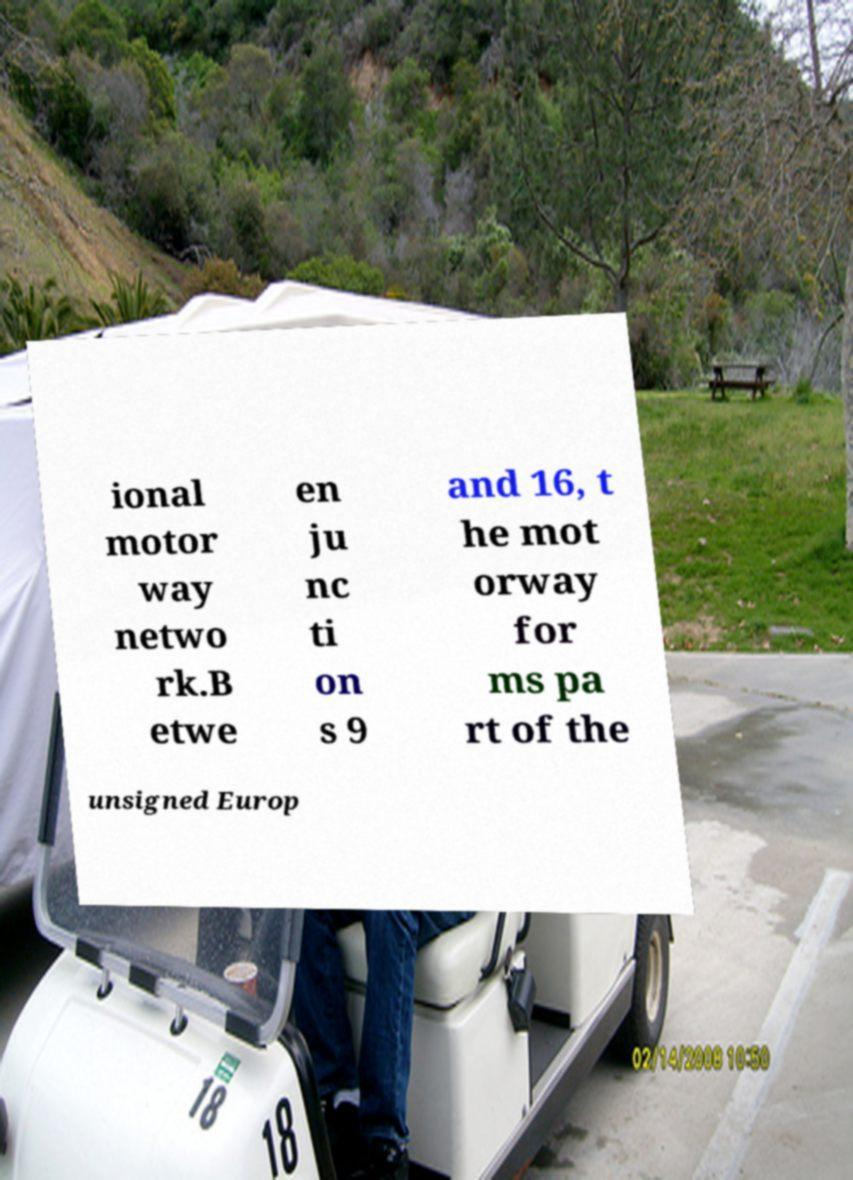Please read and relay the text visible in this image. What does it say? ional motor way netwo rk.B etwe en ju nc ti on s 9 and 16, t he mot orway for ms pa rt of the unsigned Europ 